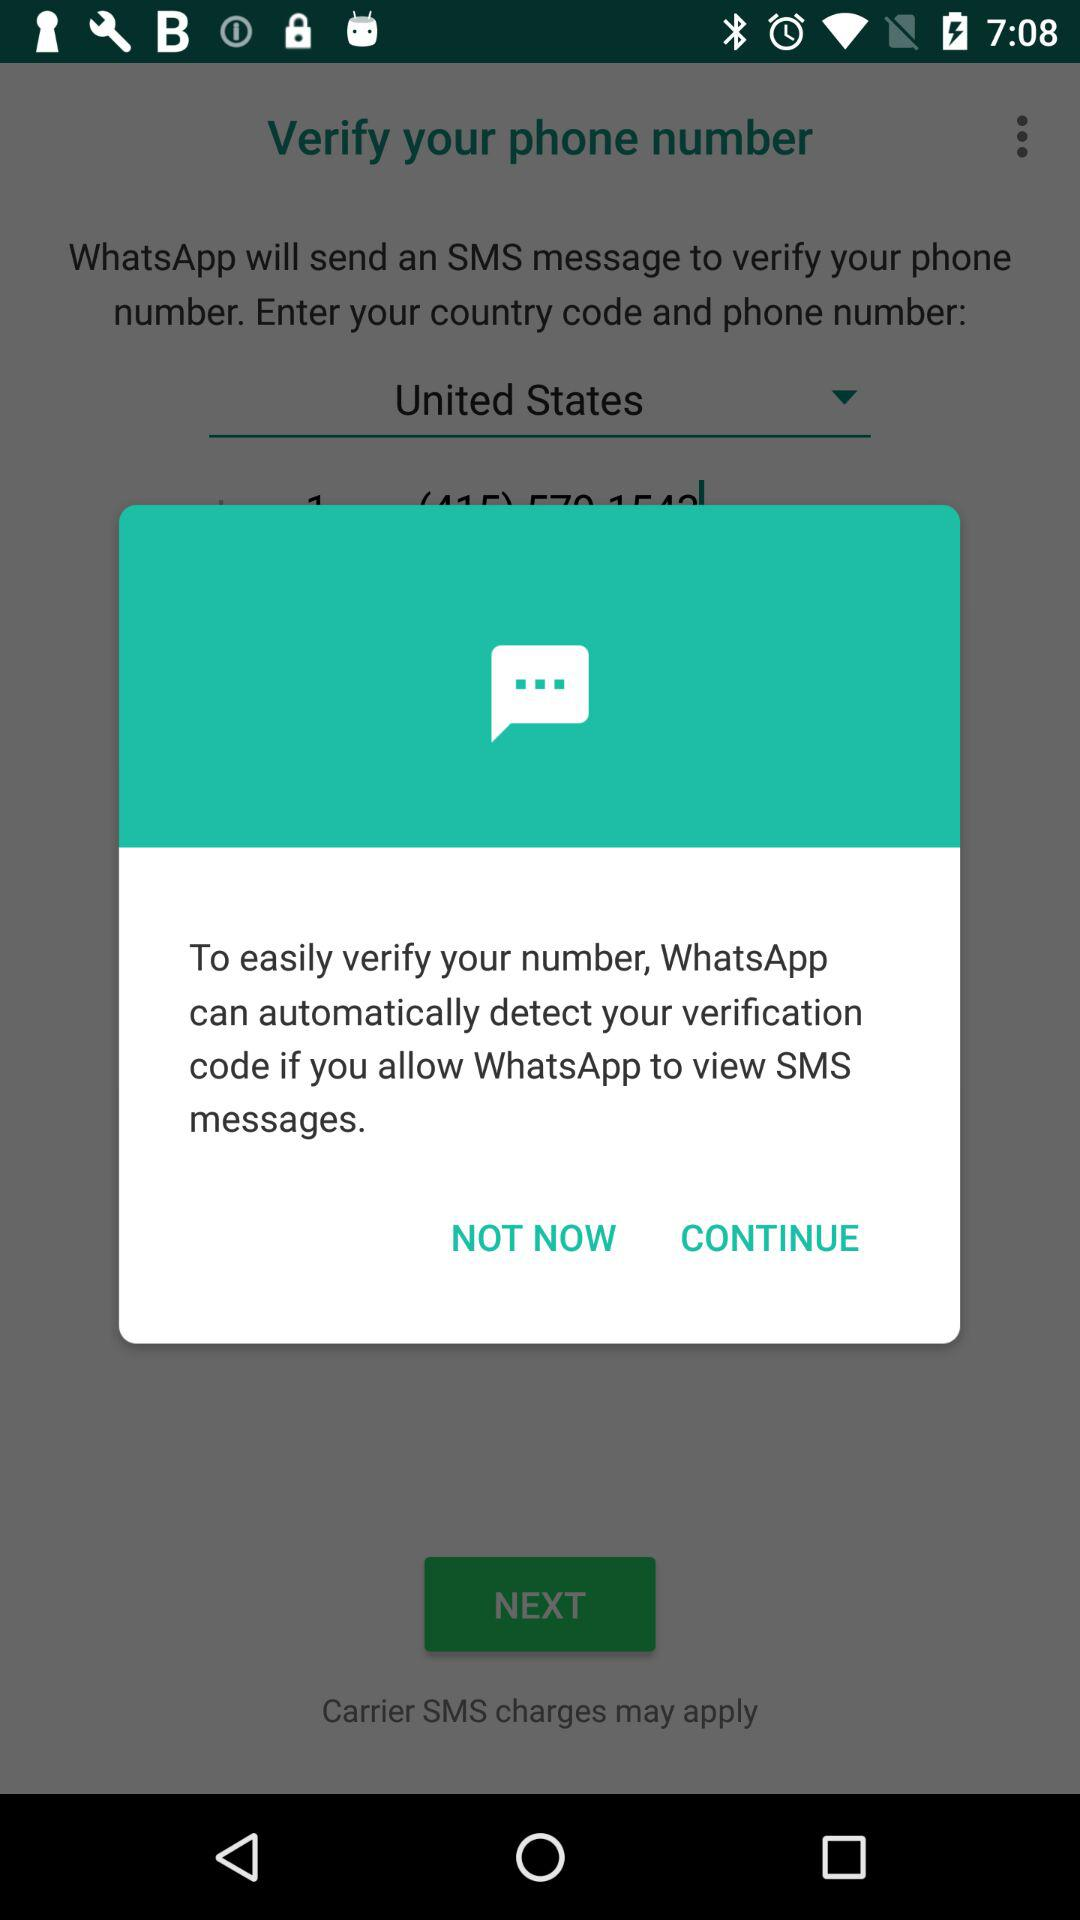What is the name of the application that can automatically detect the verification code? The name of the application that can automatically detect the verification code is "WhatsApp". 